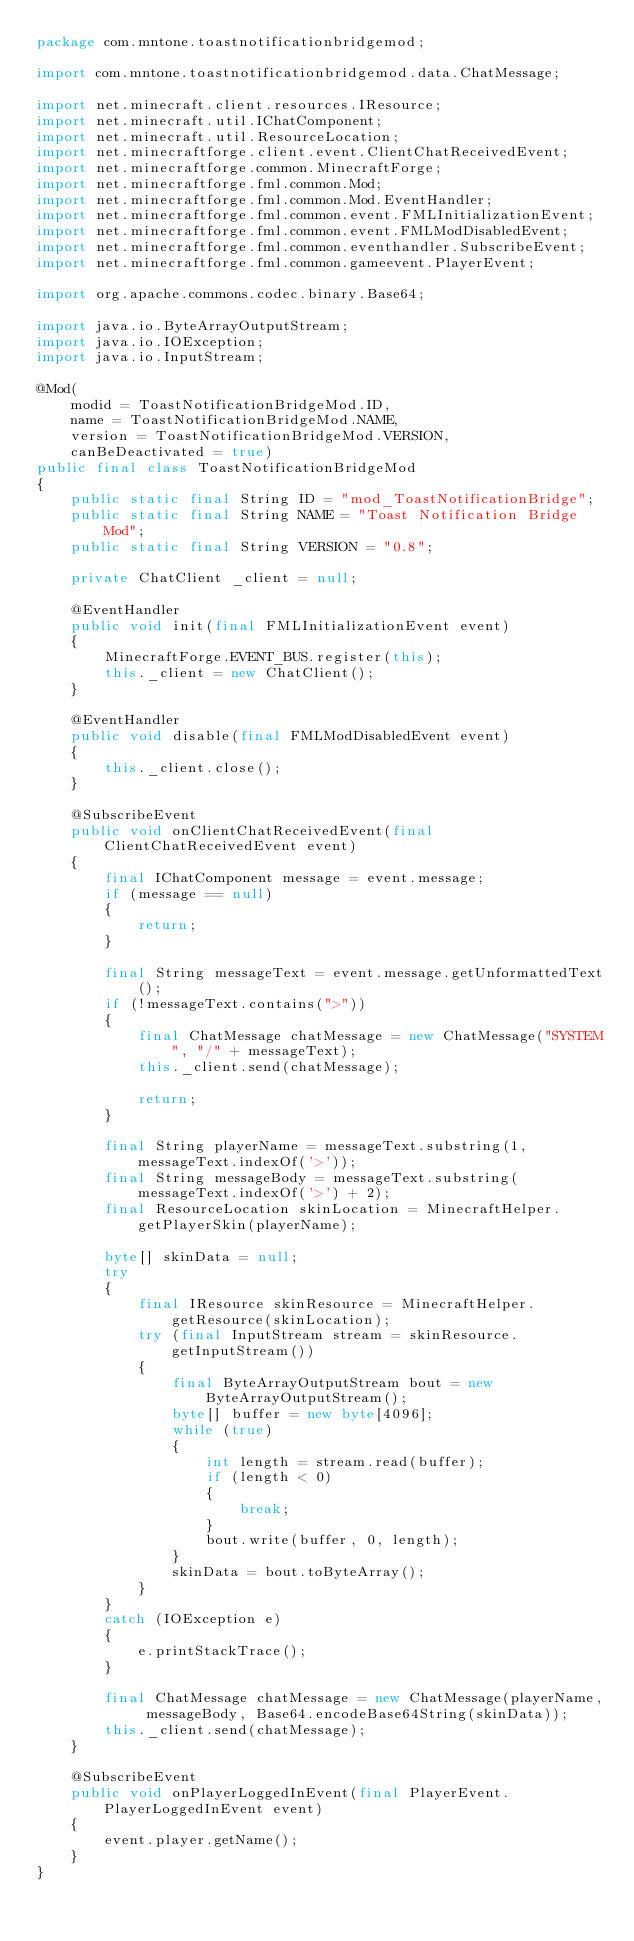Convert code to text. <code><loc_0><loc_0><loc_500><loc_500><_Java_>package com.mntone.toastnotificationbridgemod;

import com.mntone.toastnotificationbridgemod.data.ChatMessage;

import net.minecraft.client.resources.IResource;
import net.minecraft.util.IChatComponent;
import net.minecraft.util.ResourceLocation;
import net.minecraftforge.client.event.ClientChatReceivedEvent;
import net.minecraftforge.common.MinecraftForge;
import net.minecraftforge.fml.common.Mod;
import net.minecraftforge.fml.common.Mod.EventHandler;
import net.minecraftforge.fml.common.event.FMLInitializationEvent;
import net.minecraftforge.fml.common.event.FMLModDisabledEvent;
import net.minecraftforge.fml.common.eventhandler.SubscribeEvent;
import net.minecraftforge.fml.common.gameevent.PlayerEvent;

import org.apache.commons.codec.binary.Base64;

import java.io.ByteArrayOutputStream;
import java.io.IOException;
import java.io.InputStream;

@Mod(
	modid = ToastNotificationBridgeMod.ID,
	name = ToastNotificationBridgeMod.NAME,
	version = ToastNotificationBridgeMod.VERSION,
	canBeDeactivated = true)
public final class ToastNotificationBridgeMod
{
	public static final String ID = "mod_ToastNotificationBridge";
	public static final String NAME = "Toast Notification Bridge Mod";
	public static final String VERSION = "0.8";

	private ChatClient _client = null;

	@EventHandler
	public void init(final FMLInitializationEvent event)
	{
		MinecraftForge.EVENT_BUS.register(this);
		this._client = new ChatClient();
	}

	@EventHandler
	public void disable(final FMLModDisabledEvent event)
	{
		this._client.close();
	}

	@SubscribeEvent
	public void onClientChatReceivedEvent(final ClientChatReceivedEvent event)
	{
		final IChatComponent message = event.message;
		if (message == null)
		{
			return;
		}

		final String messageText = event.message.getUnformattedText();
		if (!messageText.contains(">"))
		{
			final ChatMessage chatMessage = new ChatMessage("SYSTEM", "/" + messageText);
			this._client.send(chatMessage);

			return;
		}

		final String playerName = messageText.substring(1, messageText.indexOf('>'));
		final String messageBody = messageText.substring(messageText.indexOf('>') + 2);
		final ResourceLocation skinLocation = MinecraftHelper.getPlayerSkin(playerName);

		byte[] skinData = null;
		try
		{
			final IResource skinResource = MinecraftHelper.getResource(skinLocation);
			try (final InputStream stream = skinResource.getInputStream())
			{
				final ByteArrayOutputStream bout = new ByteArrayOutputStream();
				byte[] buffer = new byte[4096];
				while (true)
				{
					int length = stream.read(buffer);
					if (length < 0)
					{
						break;
					}
					bout.write(buffer, 0, length);
				}
				skinData = bout.toByteArray();
			}
		}
		catch (IOException e)
		{
			e.printStackTrace();
		}

		final ChatMessage chatMessage = new ChatMessage(playerName, messageBody, Base64.encodeBase64String(skinData));
		this._client.send(chatMessage);
	}

	@SubscribeEvent
	public void onPlayerLoggedInEvent(final PlayerEvent.PlayerLoggedInEvent event)
	{
		event.player.getName();
	}
}
</code> 